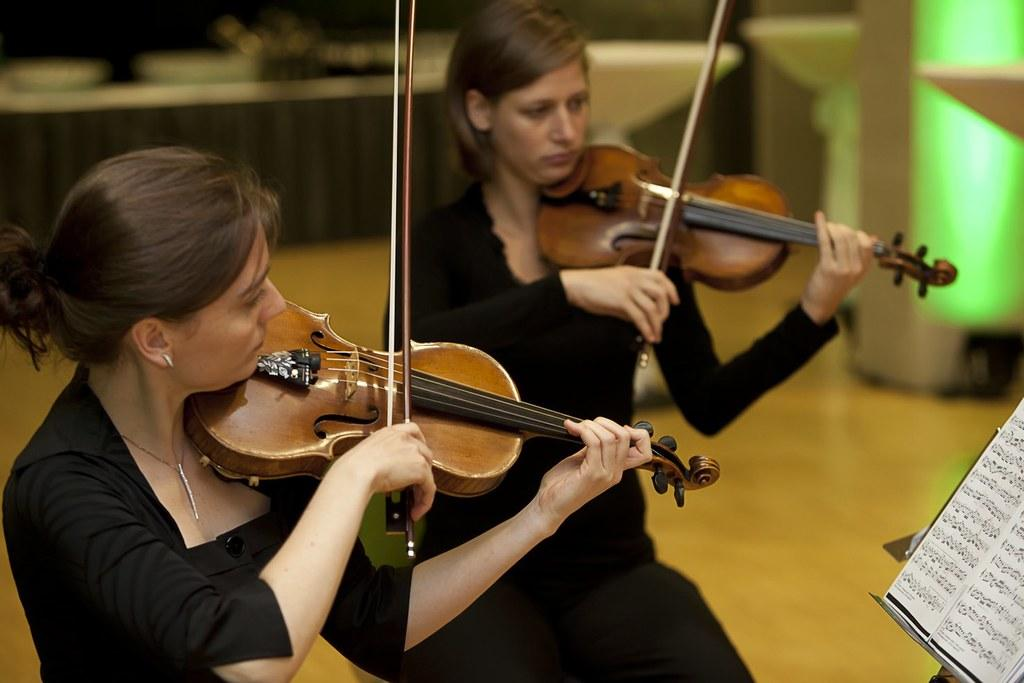How many people are in the image? There are two men in the image. What are the men doing in the image? Both men are playing a violin. Is there any other object or item visible in the image? Yes, there is a book in front of the men. Where is the pig located in the image? There is no pig present in the image. What type of rod can be seen in the image? There is no rod present in the image. 